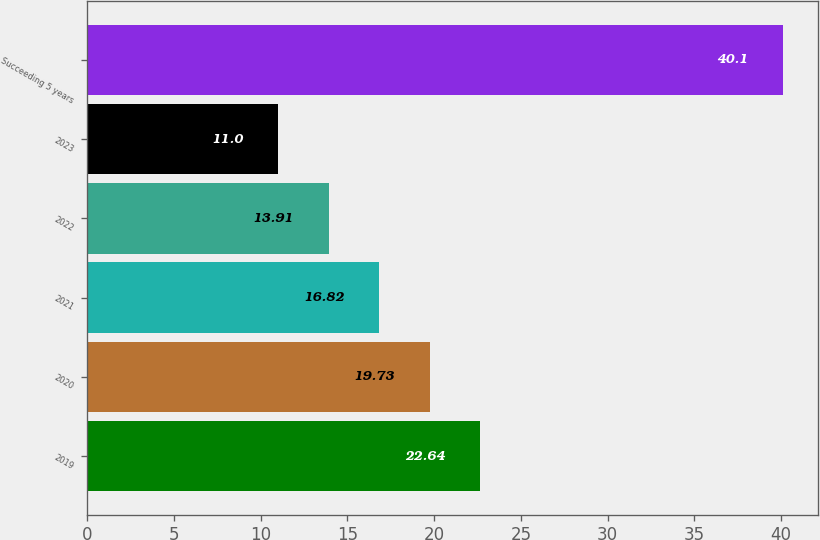Convert chart to OTSL. <chart><loc_0><loc_0><loc_500><loc_500><bar_chart><fcel>2019<fcel>2020<fcel>2021<fcel>2022<fcel>2023<fcel>Succeeding 5 years<nl><fcel>22.64<fcel>19.73<fcel>16.82<fcel>13.91<fcel>11<fcel>40.1<nl></chart> 